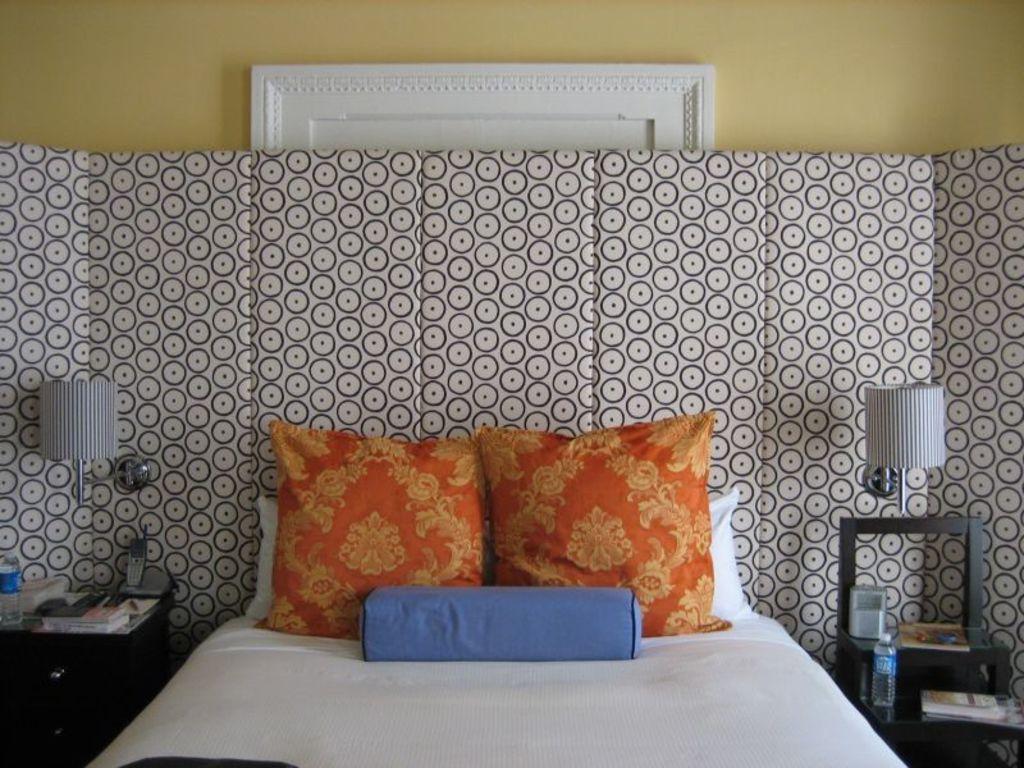Could you give a brief overview of what you see in this image? In this picture I can see the inside view of a room and in the center of this picture I can see the bed on which there are cushions and on the both sides of this picture I can see the tables, on which there are lamps, 2 bottles and other things. In the background I can see the wall and a white color thing. 